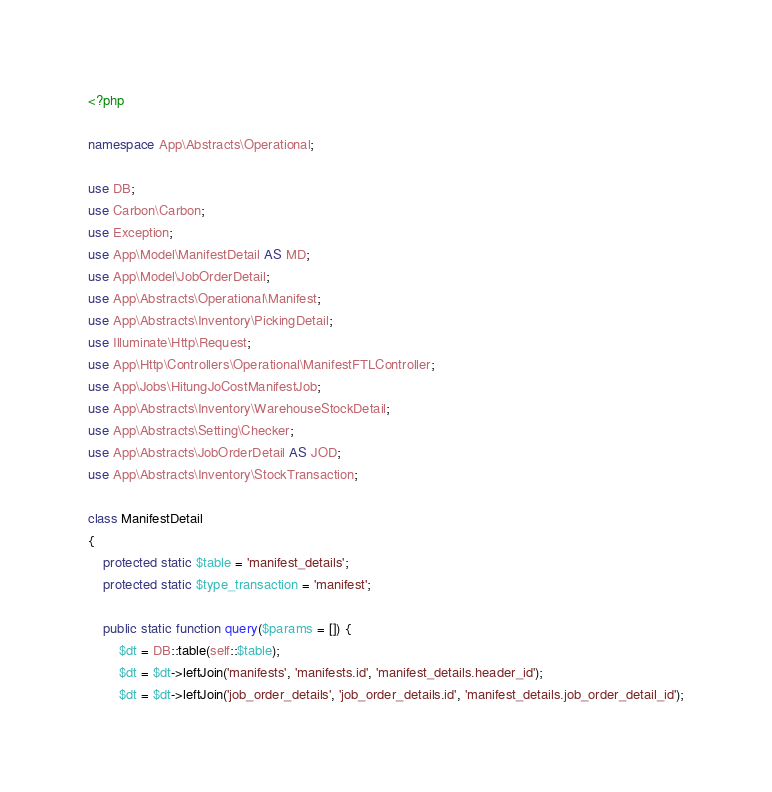Convert code to text. <code><loc_0><loc_0><loc_500><loc_500><_PHP_><?php

namespace App\Abstracts\Operational;

use DB;
use Carbon\Carbon;
use Exception;
use App\Model\ManifestDetail AS MD;
use App\Model\JobOrderDetail;
use App\Abstracts\Operational\Manifest;
use App\Abstracts\Inventory\PickingDetail;
use Illuminate\Http\Request;
use App\Http\Controllers\Operational\ManifestFTLController;
use App\Jobs\HitungJoCostManifestJob;
use App\Abstracts\Inventory\WarehouseStockDetail;
use App\Abstracts\Setting\Checker;
use App\Abstracts\JobOrderDetail AS JOD;
use App\Abstracts\Inventory\StockTransaction;

class ManifestDetail
{
    protected static $table = 'manifest_details';
    protected static $type_transaction = 'manifest';

    public static function query($params = []) {
        $dt = DB::table(self::$table);
        $dt = $dt->leftJoin('manifests', 'manifests.id', 'manifest_details.header_id');
        $dt = $dt->leftJoin('job_order_details', 'job_order_details.id', 'manifest_details.job_order_detail_id');</code> 